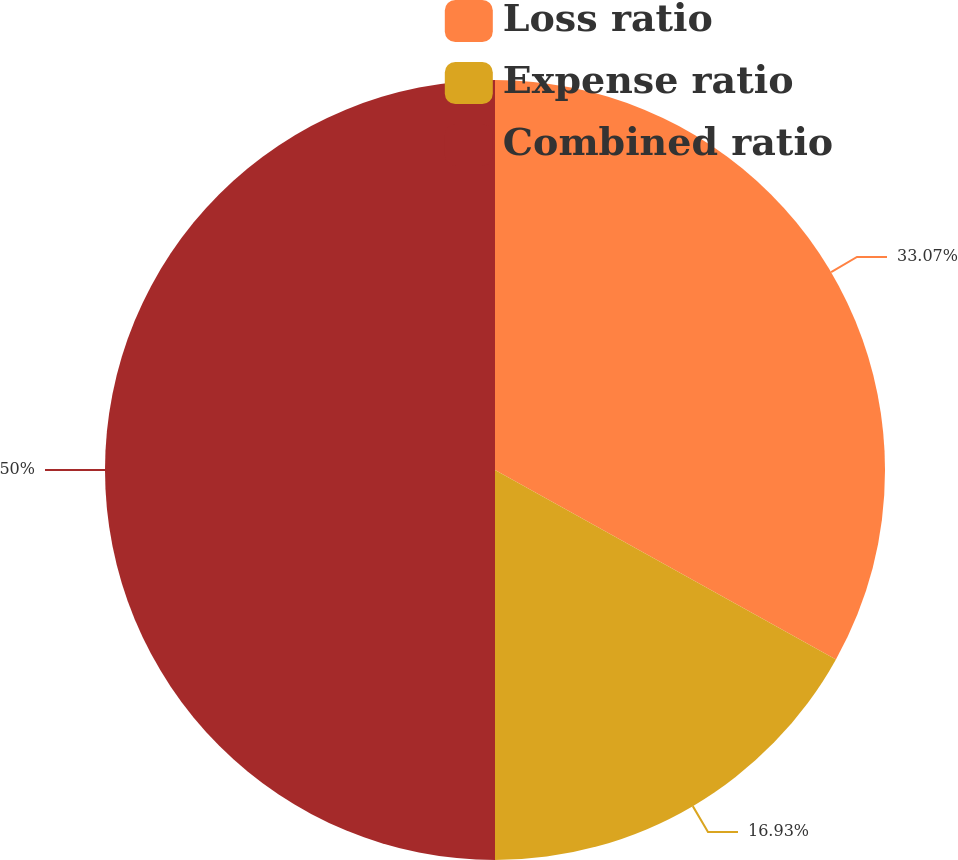<chart> <loc_0><loc_0><loc_500><loc_500><pie_chart><fcel>Loss ratio<fcel>Expense ratio<fcel>Combined ratio<nl><fcel>33.07%<fcel>16.93%<fcel>50.0%<nl></chart> 